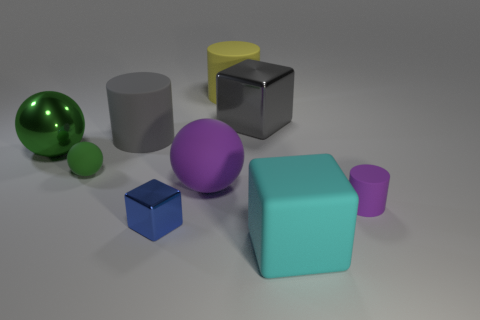What is the shape of the tiny matte object to the left of the big metal object right of the big gray matte object?
Your response must be concise. Sphere. Is there anything else of the same color as the big metallic sphere?
Offer a very short reply. Yes. There is a blue block; is it the same size as the metal object that is on the right side of the large yellow cylinder?
Your response must be concise. No. What number of big objects are gray metallic objects or rubber cubes?
Keep it short and to the point. 2. Are there more tiny metallic cubes than cyan shiny objects?
Your response must be concise. Yes. What number of tiny matte things are in front of the tiny rubber object to the left of the big gray object right of the yellow rubber cylinder?
Make the answer very short. 1. What shape is the big yellow rubber thing?
Your response must be concise. Cylinder. What number of other objects are the same material as the blue thing?
Offer a terse response. 2. Does the shiny ball have the same size as the purple matte sphere?
Ensure brevity in your answer.  Yes. What is the shape of the metallic object right of the big yellow matte cylinder?
Ensure brevity in your answer.  Cube. 